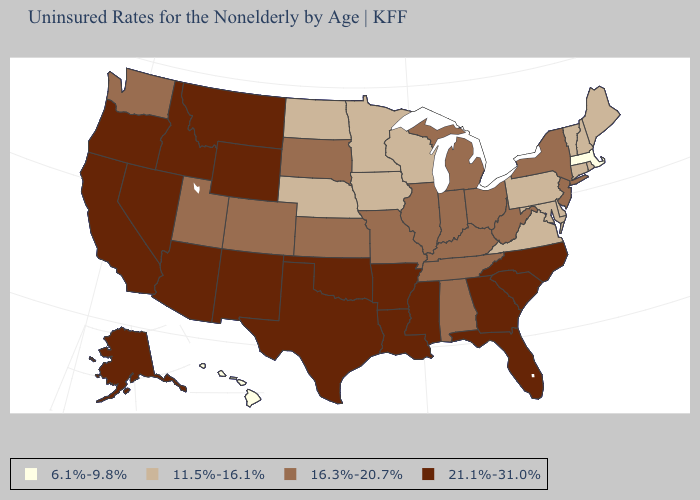Which states have the highest value in the USA?
Write a very short answer. Alaska, Arizona, Arkansas, California, Florida, Georgia, Idaho, Louisiana, Mississippi, Montana, Nevada, New Mexico, North Carolina, Oklahoma, Oregon, South Carolina, Texas, Wyoming. What is the highest value in the USA?
Give a very brief answer. 21.1%-31.0%. Which states have the lowest value in the South?
Write a very short answer. Delaware, Maryland, Virginia. What is the value of Ohio?
Give a very brief answer. 16.3%-20.7%. Name the states that have a value in the range 16.3%-20.7%?
Answer briefly. Alabama, Colorado, Illinois, Indiana, Kansas, Kentucky, Michigan, Missouri, New Jersey, New York, Ohio, South Dakota, Tennessee, Utah, Washington, West Virginia. Among the states that border Wyoming , does Nebraska have the lowest value?
Keep it brief. Yes. Name the states that have a value in the range 6.1%-9.8%?
Short answer required. Hawaii, Massachusetts. What is the lowest value in the South?
Give a very brief answer. 11.5%-16.1%. Does Massachusetts have the lowest value in the USA?
Answer briefly. Yes. Name the states that have a value in the range 11.5%-16.1%?
Answer briefly. Connecticut, Delaware, Iowa, Maine, Maryland, Minnesota, Nebraska, New Hampshire, North Dakota, Pennsylvania, Rhode Island, Vermont, Virginia, Wisconsin. What is the value of Montana?
Quick response, please. 21.1%-31.0%. Does Arkansas have the highest value in the USA?
Be succinct. Yes. Among the states that border Tennessee , does Missouri have the highest value?
Concise answer only. No. Does the first symbol in the legend represent the smallest category?
Be succinct. Yes. Does New Hampshire have the lowest value in the USA?
Short answer required. No. 